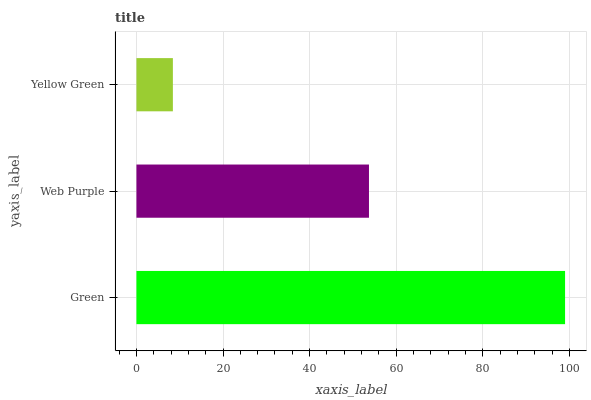Is Yellow Green the minimum?
Answer yes or no. Yes. Is Green the maximum?
Answer yes or no. Yes. Is Web Purple the minimum?
Answer yes or no. No. Is Web Purple the maximum?
Answer yes or no. No. Is Green greater than Web Purple?
Answer yes or no. Yes. Is Web Purple less than Green?
Answer yes or no. Yes. Is Web Purple greater than Green?
Answer yes or no. No. Is Green less than Web Purple?
Answer yes or no. No. Is Web Purple the high median?
Answer yes or no. Yes. Is Web Purple the low median?
Answer yes or no. Yes. Is Yellow Green the high median?
Answer yes or no. No. Is Green the low median?
Answer yes or no. No. 